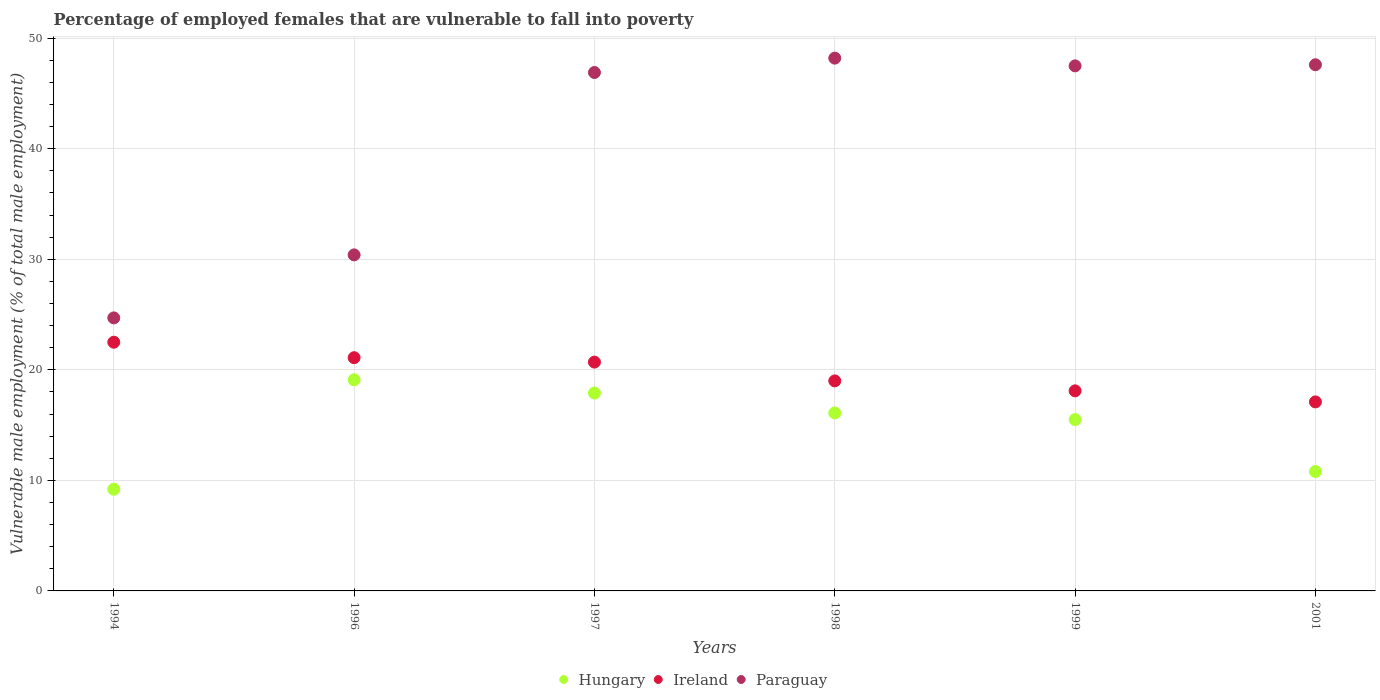Is the number of dotlines equal to the number of legend labels?
Keep it short and to the point. Yes. What is the percentage of employed females who are vulnerable to fall into poverty in Paraguay in 1999?
Offer a very short reply. 47.5. Across all years, what is the maximum percentage of employed females who are vulnerable to fall into poverty in Hungary?
Give a very brief answer. 19.1. Across all years, what is the minimum percentage of employed females who are vulnerable to fall into poverty in Paraguay?
Your answer should be very brief. 24.7. What is the total percentage of employed females who are vulnerable to fall into poverty in Paraguay in the graph?
Provide a succinct answer. 245.3. What is the difference between the percentage of employed females who are vulnerable to fall into poverty in Ireland in 1997 and that in 2001?
Ensure brevity in your answer.  3.6. What is the difference between the percentage of employed females who are vulnerable to fall into poverty in Paraguay in 1998 and the percentage of employed females who are vulnerable to fall into poverty in Ireland in 1997?
Keep it short and to the point. 27.5. What is the average percentage of employed females who are vulnerable to fall into poverty in Hungary per year?
Offer a terse response. 14.77. In the year 1999, what is the difference between the percentage of employed females who are vulnerable to fall into poverty in Ireland and percentage of employed females who are vulnerable to fall into poverty in Paraguay?
Your answer should be compact. -29.4. What is the ratio of the percentage of employed females who are vulnerable to fall into poverty in Hungary in 1994 to that in 1998?
Provide a succinct answer. 0.57. What is the difference between the highest and the second highest percentage of employed females who are vulnerable to fall into poverty in Ireland?
Keep it short and to the point. 1.4. What is the difference between the highest and the lowest percentage of employed females who are vulnerable to fall into poverty in Paraguay?
Keep it short and to the point. 23.5. In how many years, is the percentage of employed females who are vulnerable to fall into poverty in Ireland greater than the average percentage of employed females who are vulnerable to fall into poverty in Ireland taken over all years?
Keep it short and to the point. 3. Is the sum of the percentage of employed females who are vulnerable to fall into poverty in Hungary in 1997 and 2001 greater than the maximum percentage of employed females who are vulnerable to fall into poverty in Paraguay across all years?
Your answer should be very brief. No. Does the percentage of employed females who are vulnerable to fall into poverty in Ireland monotonically increase over the years?
Ensure brevity in your answer.  No. How many dotlines are there?
Provide a short and direct response. 3. What is the difference between two consecutive major ticks on the Y-axis?
Offer a very short reply. 10. Does the graph contain any zero values?
Offer a terse response. No. Does the graph contain grids?
Keep it short and to the point. Yes. Where does the legend appear in the graph?
Keep it short and to the point. Bottom center. How are the legend labels stacked?
Give a very brief answer. Horizontal. What is the title of the graph?
Your answer should be very brief. Percentage of employed females that are vulnerable to fall into poverty. Does "Sub-Saharan Africa (all income levels)" appear as one of the legend labels in the graph?
Your response must be concise. No. What is the label or title of the X-axis?
Your answer should be very brief. Years. What is the label or title of the Y-axis?
Make the answer very short. Vulnerable male employment (% of total male employment). What is the Vulnerable male employment (% of total male employment) in Hungary in 1994?
Offer a terse response. 9.2. What is the Vulnerable male employment (% of total male employment) in Ireland in 1994?
Offer a terse response. 22.5. What is the Vulnerable male employment (% of total male employment) of Paraguay in 1994?
Your answer should be compact. 24.7. What is the Vulnerable male employment (% of total male employment) in Hungary in 1996?
Your answer should be very brief. 19.1. What is the Vulnerable male employment (% of total male employment) in Ireland in 1996?
Offer a terse response. 21.1. What is the Vulnerable male employment (% of total male employment) of Paraguay in 1996?
Make the answer very short. 30.4. What is the Vulnerable male employment (% of total male employment) in Hungary in 1997?
Provide a succinct answer. 17.9. What is the Vulnerable male employment (% of total male employment) of Ireland in 1997?
Provide a short and direct response. 20.7. What is the Vulnerable male employment (% of total male employment) of Paraguay in 1997?
Ensure brevity in your answer.  46.9. What is the Vulnerable male employment (% of total male employment) of Hungary in 1998?
Provide a succinct answer. 16.1. What is the Vulnerable male employment (% of total male employment) in Ireland in 1998?
Provide a succinct answer. 19. What is the Vulnerable male employment (% of total male employment) in Paraguay in 1998?
Give a very brief answer. 48.2. What is the Vulnerable male employment (% of total male employment) of Hungary in 1999?
Your answer should be compact. 15.5. What is the Vulnerable male employment (% of total male employment) of Ireland in 1999?
Give a very brief answer. 18.1. What is the Vulnerable male employment (% of total male employment) of Paraguay in 1999?
Your response must be concise. 47.5. What is the Vulnerable male employment (% of total male employment) in Hungary in 2001?
Provide a succinct answer. 10.8. What is the Vulnerable male employment (% of total male employment) in Ireland in 2001?
Provide a succinct answer. 17.1. What is the Vulnerable male employment (% of total male employment) in Paraguay in 2001?
Make the answer very short. 47.6. Across all years, what is the maximum Vulnerable male employment (% of total male employment) of Hungary?
Ensure brevity in your answer.  19.1. Across all years, what is the maximum Vulnerable male employment (% of total male employment) in Ireland?
Give a very brief answer. 22.5. Across all years, what is the maximum Vulnerable male employment (% of total male employment) of Paraguay?
Your answer should be compact. 48.2. Across all years, what is the minimum Vulnerable male employment (% of total male employment) in Hungary?
Provide a succinct answer. 9.2. Across all years, what is the minimum Vulnerable male employment (% of total male employment) in Ireland?
Your answer should be very brief. 17.1. Across all years, what is the minimum Vulnerable male employment (% of total male employment) in Paraguay?
Offer a very short reply. 24.7. What is the total Vulnerable male employment (% of total male employment) in Hungary in the graph?
Offer a terse response. 88.6. What is the total Vulnerable male employment (% of total male employment) of Ireland in the graph?
Offer a very short reply. 118.5. What is the total Vulnerable male employment (% of total male employment) of Paraguay in the graph?
Your answer should be very brief. 245.3. What is the difference between the Vulnerable male employment (% of total male employment) of Paraguay in 1994 and that in 1997?
Your answer should be very brief. -22.2. What is the difference between the Vulnerable male employment (% of total male employment) in Paraguay in 1994 and that in 1998?
Ensure brevity in your answer.  -23.5. What is the difference between the Vulnerable male employment (% of total male employment) in Hungary in 1994 and that in 1999?
Your answer should be compact. -6.3. What is the difference between the Vulnerable male employment (% of total male employment) in Paraguay in 1994 and that in 1999?
Keep it short and to the point. -22.8. What is the difference between the Vulnerable male employment (% of total male employment) of Hungary in 1994 and that in 2001?
Your answer should be very brief. -1.6. What is the difference between the Vulnerable male employment (% of total male employment) in Ireland in 1994 and that in 2001?
Offer a terse response. 5.4. What is the difference between the Vulnerable male employment (% of total male employment) in Paraguay in 1994 and that in 2001?
Provide a short and direct response. -22.9. What is the difference between the Vulnerable male employment (% of total male employment) of Paraguay in 1996 and that in 1997?
Keep it short and to the point. -16.5. What is the difference between the Vulnerable male employment (% of total male employment) in Hungary in 1996 and that in 1998?
Offer a terse response. 3. What is the difference between the Vulnerable male employment (% of total male employment) in Paraguay in 1996 and that in 1998?
Your response must be concise. -17.8. What is the difference between the Vulnerable male employment (% of total male employment) in Paraguay in 1996 and that in 1999?
Your answer should be compact. -17.1. What is the difference between the Vulnerable male employment (% of total male employment) in Hungary in 1996 and that in 2001?
Offer a very short reply. 8.3. What is the difference between the Vulnerable male employment (% of total male employment) of Ireland in 1996 and that in 2001?
Your answer should be compact. 4. What is the difference between the Vulnerable male employment (% of total male employment) of Paraguay in 1996 and that in 2001?
Provide a succinct answer. -17.2. What is the difference between the Vulnerable male employment (% of total male employment) in Hungary in 1997 and that in 1998?
Your response must be concise. 1.8. What is the difference between the Vulnerable male employment (% of total male employment) of Ireland in 1997 and that in 1998?
Ensure brevity in your answer.  1.7. What is the difference between the Vulnerable male employment (% of total male employment) of Hungary in 1997 and that in 1999?
Your answer should be compact. 2.4. What is the difference between the Vulnerable male employment (% of total male employment) in Paraguay in 1997 and that in 1999?
Offer a very short reply. -0.6. What is the difference between the Vulnerable male employment (% of total male employment) in Hungary in 1998 and that in 1999?
Provide a short and direct response. 0.6. What is the difference between the Vulnerable male employment (% of total male employment) in Hungary in 1998 and that in 2001?
Provide a short and direct response. 5.3. What is the difference between the Vulnerable male employment (% of total male employment) of Paraguay in 1998 and that in 2001?
Offer a terse response. 0.6. What is the difference between the Vulnerable male employment (% of total male employment) in Ireland in 1999 and that in 2001?
Provide a succinct answer. 1. What is the difference between the Vulnerable male employment (% of total male employment) of Paraguay in 1999 and that in 2001?
Give a very brief answer. -0.1. What is the difference between the Vulnerable male employment (% of total male employment) in Hungary in 1994 and the Vulnerable male employment (% of total male employment) in Ireland in 1996?
Provide a short and direct response. -11.9. What is the difference between the Vulnerable male employment (% of total male employment) of Hungary in 1994 and the Vulnerable male employment (% of total male employment) of Paraguay in 1996?
Give a very brief answer. -21.2. What is the difference between the Vulnerable male employment (% of total male employment) of Ireland in 1994 and the Vulnerable male employment (% of total male employment) of Paraguay in 1996?
Offer a very short reply. -7.9. What is the difference between the Vulnerable male employment (% of total male employment) in Hungary in 1994 and the Vulnerable male employment (% of total male employment) in Paraguay in 1997?
Ensure brevity in your answer.  -37.7. What is the difference between the Vulnerable male employment (% of total male employment) in Ireland in 1994 and the Vulnerable male employment (% of total male employment) in Paraguay in 1997?
Give a very brief answer. -24.4. What is the difference between the Vulnerable male employment (% of total male employment) in Hungary in 1994 and the Vulnerable male employment (% of total male employment) in Ireland in 1998?
Ensure brevity in your answer.  -9.8. What is the difference between the Vulnerable male employment (% of total male employment) of Hungary in 1994 and the Vulnerable male employment (% of total male employment) of Paraguay in 1998?
Ensure brevity in your answer.  -39. What is the difference between the Vulnerable male employment (% of total male employment) in Ireland in 1994 and the Vulnerable male employment (% of total male employment) in Paraguay in 1998?
Provide a succinct answer. -25.7. What is the difference between the Vulnerable male employment (% of total male employment) in Hungary in 1994 and the Vulnerable male employment (% of total male employment) in Ireland in 1999?
Your response must be concise. -8.9. What is the difference between the Vulnerable male employment (% of total male employment) of Hungary in 1994 and the Vulnerable male employment (% of total male employment) of Paraguay in 1999?
Make the answer very short. -38.3. What is the difference between the Vulnerable male employment (% of total male employment) of Ireland in 1994 and the Vulnerable male employment (% of total male employment) of Paraguay in 1999?
Provide a short and direct response. -25. What is the difference between the Vulnerable male employment (% of total male employment) in Hungary in 1994 and the Vulnerable male employment (% of total male employment) in Paraguay in 2001?
Provide a short and direct response. -38.4. What is the difference between the Vulnerable male employment (% of total male employment) of Ireland in 1994 and the Vulnerable male employment (% of total male employment) of Paraguay in 2001?
Your answer should be very brief. -25.1. What is the difference between the Vulnerable male employment (% of total male employment) of Hungary in 1996 and the Vulnerable male employment (% of total male employment) of Paraguay in 1997?
Offer a terse response. -27.8. What is the difference between the Vulnerable male employment (% of total male employment) of Ireland in 1996 and the Vulnerable male employment (% of total male employment) of Paraguay in 1997?
Your response must be concise. -25.8. What is the difference between the Vulnerable male employment (% of total male employment) of Hungary in 1996 and the Vulnerable male employment (% of total male employment) of Paraguay in 1998?
Offer a very short reply. -29.1. What is the difference between the Vulnerable male employment (% of total male employment) in Ireland in 1996 and the Vulnerable male employment (% of total male employment) in Paraguay in 1998?
Your response must be concise. -27.1. What is the difference between the Vulnerable male employment (% of total male employment) of Hungary in 1996 and the Vulnerable male employment (% of total male employment) of Paraguay in 1999?
Provide a short and direct response. -28.4. What is the difference between the Vulnerable male employment (% of total male employment) in Ireland in 1996 and the Vulnerable male employment (% of total male employment) in Paraguay in 1999?
Provide a succinct answer. -26.4. What is the difference between the Vulnerable male employment (% of total male employment) in Hungary in 1996 and the Vulnerable male employment (% of total male employment) in Ireland in 2001?
Your answer should be very brief. 2. What is the difference between the Vulnerable male employment (% of total male employment) in Hungary in 1996 and the Vulnerable male employment (% of total male employment) in Paraguay in 2001?
Your answer should be very brief. -28.5. What is the difference between the Vulnerable male employment (% of total male employment) of Ireland in 1996 and the Vulnerable male employment (% of total male employment) of Paraguay in 2001?
Ensure brevity in your answer.  -26.5. What is the difference between the Vulnerable male employment (% of total male employment) in Hungary in 1997 and the Vulnerable male employment (% of total male employment) in Ireland in 1998?
Your response must be concise. -1.1. What is the difference between the Vulnerable male employment (% of total male employment) in Hungary in 1997 and the Vulnerable male employment (% of total male employment) in Paraguay in 1998?
Keep it short and to the point. -30.3. What is the difference between the Vulnerable male employment (% of total male employment) of Ireland in 1997 and the Vulnerable male employment (% of total male employment) of Paraguay in 1998?
Your response must be concise. -27.5. What is the difference between the Vulnerable male employment (% of total male employment) in Hungary in 1997 and the Vulnerable male employment (% of total male employment) in Ireland in 1999?
Ensure brevity in your answer.  -0.2. What is the difference between the Vulnerable male employment (% of total male employment) in Hungary in 1997 and the Vulnerable male employment (% of total male employment) in Paraguay in 1999?
Provide a succinct answer. -29.6. What is the difference between the Vulnerable male employment (% of total male employment) of Ireland in 1997 and the Vulnerable male employment (% of total male employment) of Paraguay in 1999?
Provide a succinct answer. -26.8. What is the difference between the Vulnerable male employment (% of total male employment) of Hungary in 1997 and the Vulnerable male employment (% of total male employment) of Paraguay in 2001?
Provide a succinct answer. -29.7. What is the difference between the Vulnerable male employment (% of total male employment) in Ireland in 1997 and the Vulnerable male employment (% of total male employment) in Paraguay in 2001?
Offer a terse response. -26.9. What is the difference between the Vulnerable male employment (% of total male employment) of Hungary in 1998 and the Vulnerable male employment (% of total male employment) of Ireland in 1999?
Offer a terse response. -2. What is the difference between the Vulnerable male employment (% of total male employment) in Hungary in 1998 and the Vulnerable male employment (% of total male employment) in Paraguay in 1999?
Your response must be concise. -31.4. What is the difference between the Vulnerable male employment (% of total male employment) of Ireland in 1998 and the Vulnerable male employment (% of total male employment) of Paraguay in 1999?
Your answer should be very brief. -28.5. What is the difference between the Vulnerable male employment (% of total male employment) of Hungary in 1998 and the Vulnerable male employment (% of total male employment) of Ireland in 2001?
Ensure brevity in your answer.  -1. What is the difference between the Vulnerable male employment (% of total male employment) in Hungary in 1998 and the Vulnerable male employment (% of total male employment) in Paraguay in 2001?
Your answer should be very brief. -31.5. What is the difference between the Vulnerable male employment (% of total male employment) of Ireland in 1998 and the Vulnerable male employment (% of total male employment) of Paraguay in 2001?
Give a very brief answer. -28.6. What is the difference between the Vulnerable male employment (% of total male employment) of Hungary in 1999 and the Vulnerable male employment (% of total male employment) of Paraguay in 2001?
Offer a very short reply. -32.1. What is the difference between the Vulnerable male employment (% of total male employment) of Ireland in 1999 and the Vulnerable male employment (% of total male employment) of Paraguay in 2001?
Provide a succinct answer. -29.5. What is the average Vulnerable male employment (% of total male employment) of Hungary per year?
Your answer should be very brief. 14.77. What is the average Vulnerable male employment (% of total male employment) of Ireland per year?
Make the answer very short. 19.75. What is the average Vulnerable male employment (% of total male employment) in Paraguay per year?
Offer a terse response. 40.88. In the year 1994, what is the difference between the Vulnerable male employment (% of total male employment) of Hungary and Vulnerable male employment (% of total male employment) of Paraguay?
Your response must be concise. -15.5. In the year 1994, what is the difference between the Vulnerable male employment (% of total male employment) of Ireland and Vulnerable male employment (% of total male employment) of Paraguay?
Your answer should be compact. -2.2. In the year 1996, what is the difference between the Vulnerable male employment (% of total male employment) of Hungary and Vulnerable male employment (% of total male employment) of Ireland?
Make the answer very short. -2. In the year 1996, what is the difference between the Vulnerable male employment (% of total male employment) of Hungary and Vulnerable male employment (% of total male employment) of Paraguay?
Your answer should be very brief. -11.3. In the year 1996, what is the difference between the Vulnerable male employment (% of total male employment) of Ireland and Vulnerable male employment (% of total male employment) of Paraguay?
Provide a short and direct response. -9.3. In the year 1997, what is the difference between the Vulnerable male employment (% of total male employment) of Hungary and Vulnerable male employment (% of total male employment) of Ireland?
Provide a succinct answer. -2.8. In the year 1997, what is the difference between the Vulnerable male employment (% of total male employment) of Hungary and Vulnerable male employment (% of total male employment) of Paraguay?
Offer a terse response. -29. In the year 1997, what is the difference between the Vulnerable male employment (% of total male employment) of Ireland and Vulnerable male employment (% of total male employment) of Paraguay?
Provide a succinct answer. -26.2. In the year 1998, what is the difference between the Vulnerable male employment (% of total male employment) in Hungary and Vulnerable male employment (% of total male employment) in Paraguay?
Make the answer very short. -32.1. In the year 1998, what is the difference between the Vulnerable male employment (% of total male employment) of Ireland and Vulnerable male employment (% of total male employment) of Paraguay?
Offer a very short reply. -29.2. In the year 1999, what is the difference between the Vulnerable male employment (% of total male employment) of Hungary and Vulnerable male employment (% of total male employment) of Paraguay?
Provide a short and direct response. -32. In the year 1999, what is the difference between the Vulnerable male employment (% of total male employment) in Ireland and Vulnerable male employment (% of total male employment) in Paraguay?
Your answer should be very brief. -29.4. In the year 2001, what is the difference between the Vulnerable male employment (% of total male employment) in Hungary and Vulnerable male employment (% of total male employment) in Ireland?
Ensure brevity in your answer.  -6.3. In the year 2001, what is the difference between the Vulnerable male employment (% of total male employment) of Hungary and Vulnerable male employment (% of total male employment) of Paraguay?
Ensure brevity in your answer.  -36.8. In the year 2001, what is the difference between the Vulnerable male employment (% of total male employment) of Ireland and Vulnerable male employment (% of total male employment) of Paraguay?
Offer a terse response. -30.5. What is the ratio of the Vulnerable male employment (% of total male employment) of Hungary in 1994 to that in 1996?
Give a very brief answer. 0.48. What is the ratio of the Vulnerable male employment (% of total male employment) of Ireland in 1994 to that in 1996?
Offer a very short reply. 1.07. What is the ratio of the Vulnerable male employment (% of total male employment) of Paraguay in 1994 to that in 1996?
Your answer should be compact. 0.81. What is the ratio of the Vulnerable male employment (% of total male employment) of Hungary in 1994 to that in 1997?
Keep it short and to the point. 0.51. What is the ratio of the Vulnerable male employment (% of total male employment) in Ireland in 1994 to that in 1997?
Provide a succinct answer. 1.09. What is the ratio of the Vulnerable male employment (% of total male employment) of Paraguay in 1994 to that in 1997?
Your answer should be very brief. 0.53. What is the ratio of the Vulnerable male employment (% of total male employment) of Ireland in 1994 to that in 1998?
Your response must be concise. 1.18. What is the ratio of the Vulnerable male employment (% of total male employment) of Paraguay in 1994 to that in 1998?
Make the answer very short. 0.51. What is the ratio of the Vulnerable male employment (% of total male employment) of Hungary in 1994 to that in 1999?
Ensure brevity in your answer.  0.59. What is the ratio of the Vulnerable male employment (% of total male employment) in Ireland in 1994 to that in 1999?
Make the answer very short. 1.24. What is the ratio of the Vulnerable male employment (% of total male employment) in Paraguay in 1994 to that in 1999?
Your response must be concise. 0.52. What is the ratio of the Vulnerable male employment (% of total male employment) of Hungary in 1994 to that in 2001?
Offer a very short reply. 0.85. What is the ratio of the Vulnerable male employment (% of total male employment) of Ireland in 1994 to that in 2001?
Give a very brief answer. 1.32. What is the ratio of the Vulnerable male employment (% of total male employment) in Paraguay in 1994 to that in 2001?
Give a very brief answer. 0.52. What is the ratio of the Vulnerable male employment (% of total male employment) in Hungary in 1996 to that in 1997?
Your answer should be compact. 1.07. What is the ratio of the Vulnerable male employment (% of total male employment) of Ireland in 1996 to that in 1997?
Your answer should be very brief. 1.02. What is the ratio of the Vulnerable male employment (% of total male employment) of Paraguay in 1996 to that in 1997?
Ensure brevity in your answer.  0.65. What is the ratio of the Vulnerable male employment (% of total male employment) in Hungary in 1996 to that in 1998?
Your answer should be compact. 1.19. What is the ratio of the Vulnerable male employment (% of total male employment) of Ireland in 1996 to that in 1998?
Ensure brevity in your answer.  1.11. What is the ratio of the Vulnerable male employment (% of total male employment) of Paraguay in 1996 to that in 1998?
Provide a short and direct response. 0.63. What is the ratio of the Vulnerable male employment (% of total male employment) of Hungary in 1996 to that in 1999?
Provide a short and direct response. 1.23. What is the ratio of the Vulnerable male employment (% of total male employment) in Ireland in 1996 to that in 1999?
Keep it short and to the point. 1.17. What is the ratio of the Vulnerable male employment (% of total male employment) of Paraguay in 1996 to that in 1999?
Offer a terse response. 0.64. What is the ratio of the Vulnerable male employment (% of total male employment) of Hungary in 1996 to that in 2001?
Your response must be concise. 1.77. What is the ratio of the Vulnerable male employment (% of total male employment) of Ireland in 1996 to that in 2001?
Your answer should be very brief. 1.23. What is the ratio of the Vulnerable male employment (% of total male employment) of Paraguay in 1996 to that in 2001?
Your answer should be compact. 0.64. What is the ratio of the Vulnerable male employment (% of total male employment) of Hungary in 1997 to that in 1998?
Keep it short and to the point. 1.11. What is the ratio of the Vulnerable male employment (% of total male employment) in Ireland in 1997 to that in 1998?
Your answer should be compact. 1.09. What is the ratio of the Vulnerable male employment (% of total male employment) of Hungary in 1997 to that in 1999?
Ensure brevity in your answer.  1.15. What is the ratio of the Vulnerable male employment (% of total male employment) of Ireland in 1997 to that in 1999?
Offer a terse response. 1.14. What is the ratio of the Vulnerable male employment (% of total male employment) of Paraguay in 1997 to that in 1999?
Provide a succinct answer. 0.99. What is the ratio of the Vulnerable male employment (% of total male employment) of Hungary in 1997 to that in 2001?
Make the answer very short. 1.66. What is the ratio of the Vulnerable male employment (% of total male employment) of Ireland in 1997 to that in 2001?
Your response must be concise. 1.21. What is the ratio of the Vulnerable male employment (% of total male employment) of Hungary in 1998 to that in 1999?
Ensure brevity in your answer.  1.04. What is the ratio of the Vulnerable male employment (% of total male employment) in Ireland in 1998 to that in 1999?
Offer a terse response. 1.05. What is the ratio of the Vulnerable male employment (% of total male employment) in Paraguay in 1998 to that in 1999?
Your answer should be compact. 1.01. What is the ratio of the Vulnerable male employment (% of total male employment) in Hungary in 1998 to that in 2001?
Offer a very short reply. 1.49. What is the ratio of the Vulnerable male employment (% of total male employment) in Ireland in 1998 to that in 2001?
Keep it short and to the point. 1.11. What is the ratio of the Vulnerable male employment (% of total male employment) in Paraguay in 1998 to that in 2001?
Provide a succinct answer. 1.01. What is the ratio of the Vulnerable male employment (% of total male employment) of Hungary in 1999 to that in 2001?
Provide a short and direct response. 1.44. What is the ratio of the Vulnerable male employment (% of total male employment) of Ireland in 1999 to that in 2001?
Your answer should be compact. 1.06. What is the difference between the highest and the second highest Vulnerable male employment (% of total male employment) of Hungary?
Ensure brevity in your answer.  1.2. 